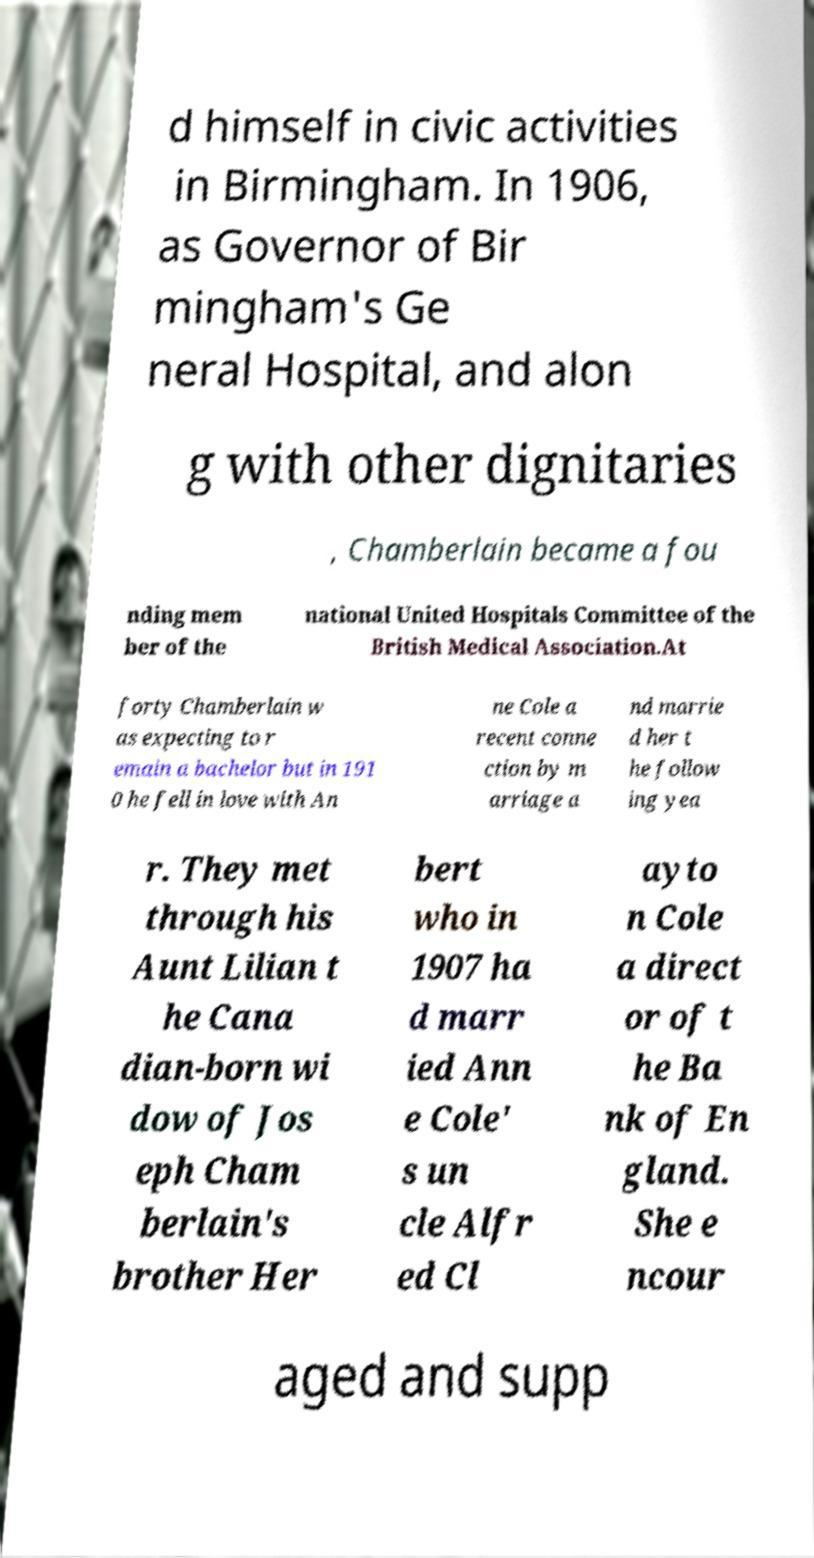Could you extract and type out the text from this image? d himself in civic activities in Birmingham. In 1906, as Governor of Bir mingham's Ge neral Hospital, and alon g with other dignitaries , Chamberlain became a fou nding mem ber of the national United Hospitals Committee of the British Medical Association.At forty Chamberlain w as expecting to r emain a bachelor but in 191 0 he fell in love with An ne Cole a recent conne ction by m arriage a nd marrie d her t he follow ing yea r. They met through his Aunt Lilian t he Cana dian-born wi dow of Jos eph Cham berlain's brother Her bert who in 1907 ha d marr ied Ann e Cole' s un cle Alfr ed Cl ayto n Cole a direct or of t he Ba nk of En gland. She e ncour aged and supp 